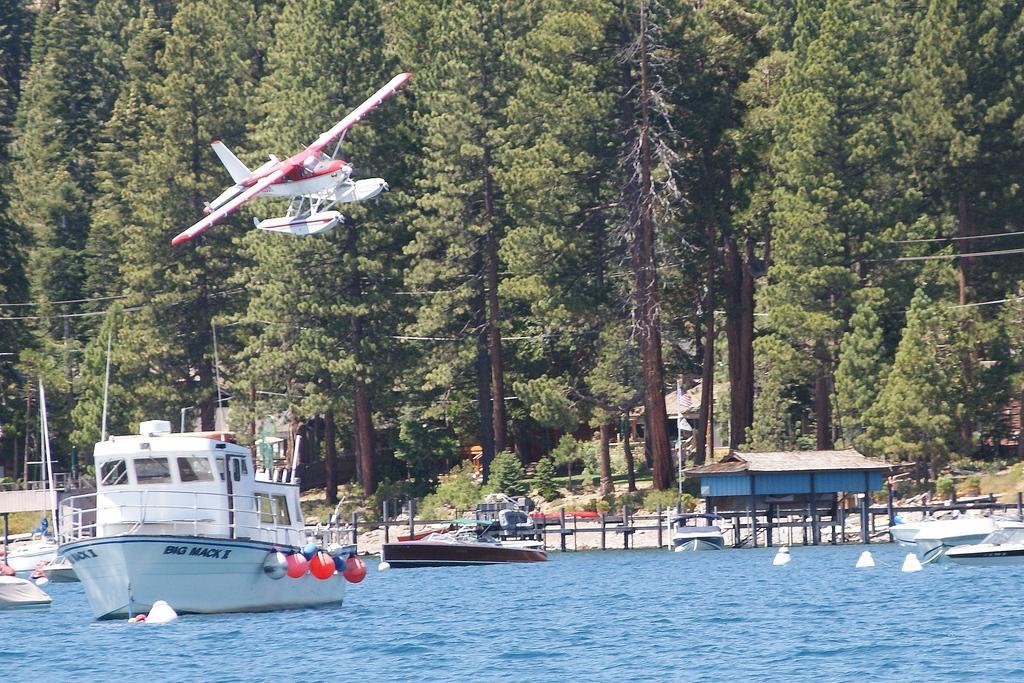In one or two sentences, can you explain what this image depicts? In this image I can see few boats on the water. In front the boat is in white color and I can also see an aircraft. Background I can see few buildings, light poles and the trees are in green color. 